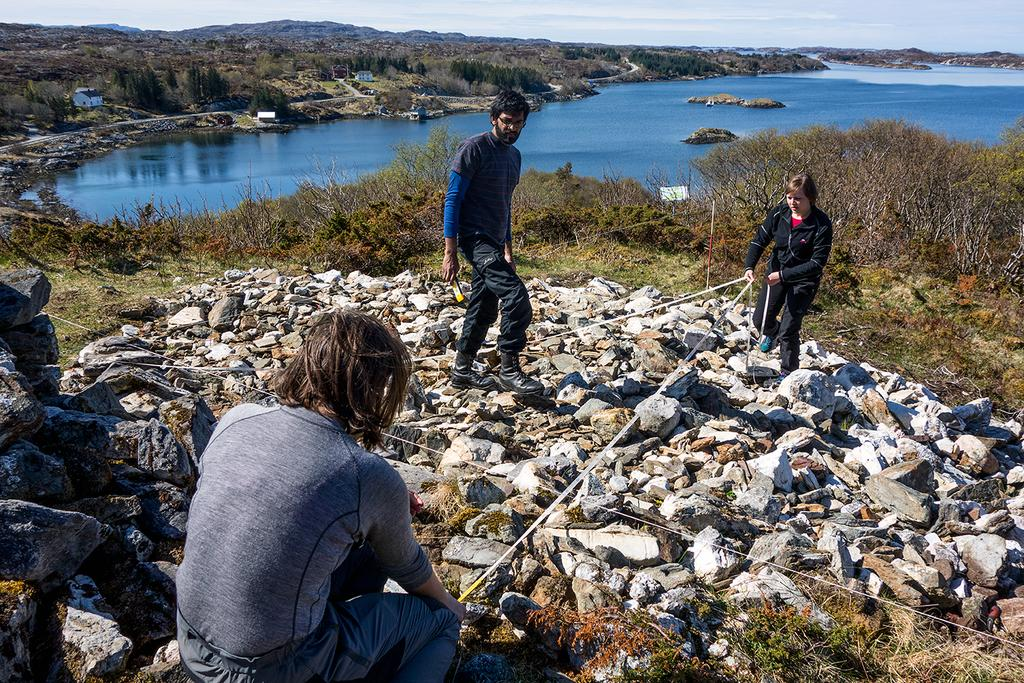What can be seen in the image related to people? There are persons wearing clothes in the image. What is located in the middle of the image? There are plants and rocks in the middle of the image. What body of water is visible at the top of the image? There is a lake at the top of the image. What type of art can be seen in the image? There is no art present in the image; it features persons, plants, rocks, and a lake. Is there a fight happening in the image? There is no fight depicted in the image. 